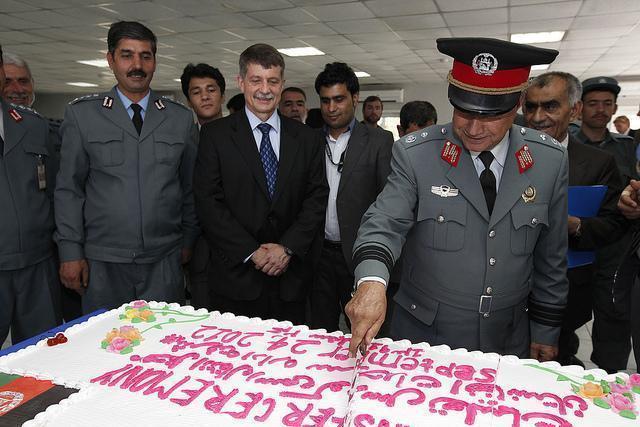Why is the man reaching towards the cake?
Choose the right answer from the provided options to respond to the question.
Options: To smash, to decorate, to wipe, to cut. To cut. 